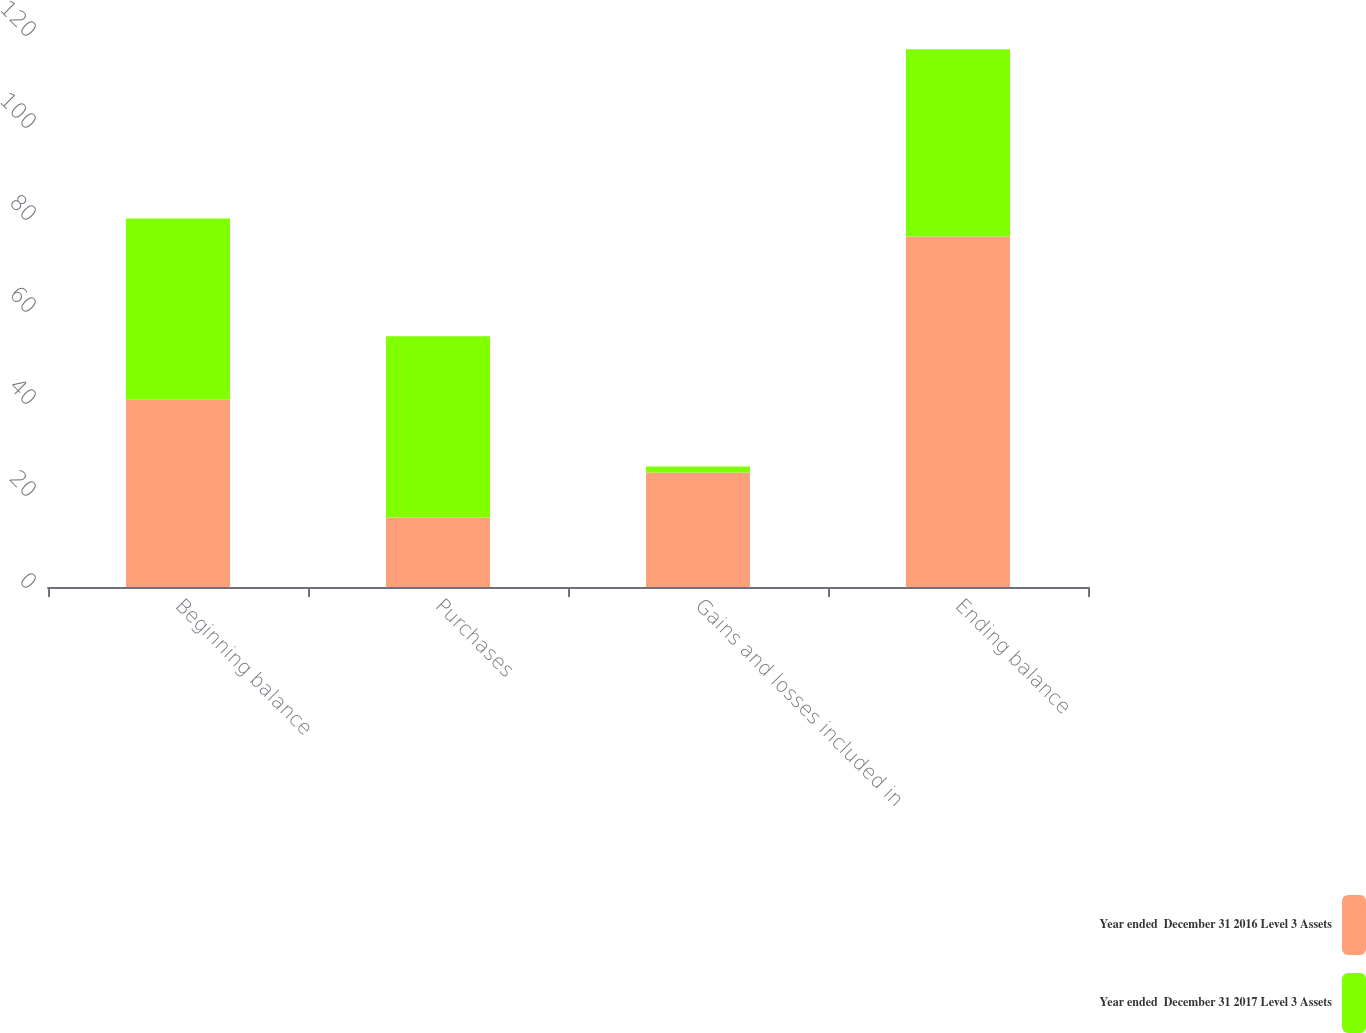<chart> <loc_0><loc_0><loc_500><loc_500><stacked_bar_chart><ecel><fcel>Beginning balance<fcel>Purchases<fcel>Gains and losses included in<fcel>Ending balance<nl><fcel>Year ended  December 31 2016 Level 3 Assets<fcel>40.7<fcel>15.1<fcel>24.9<fcel>76.2<nl><fcel>Year ended  December 31 2017 Level 3 Assets<fcel>39.4<fcel>39.4<fcel>1.3<fcel>40.7<nl></chart> 